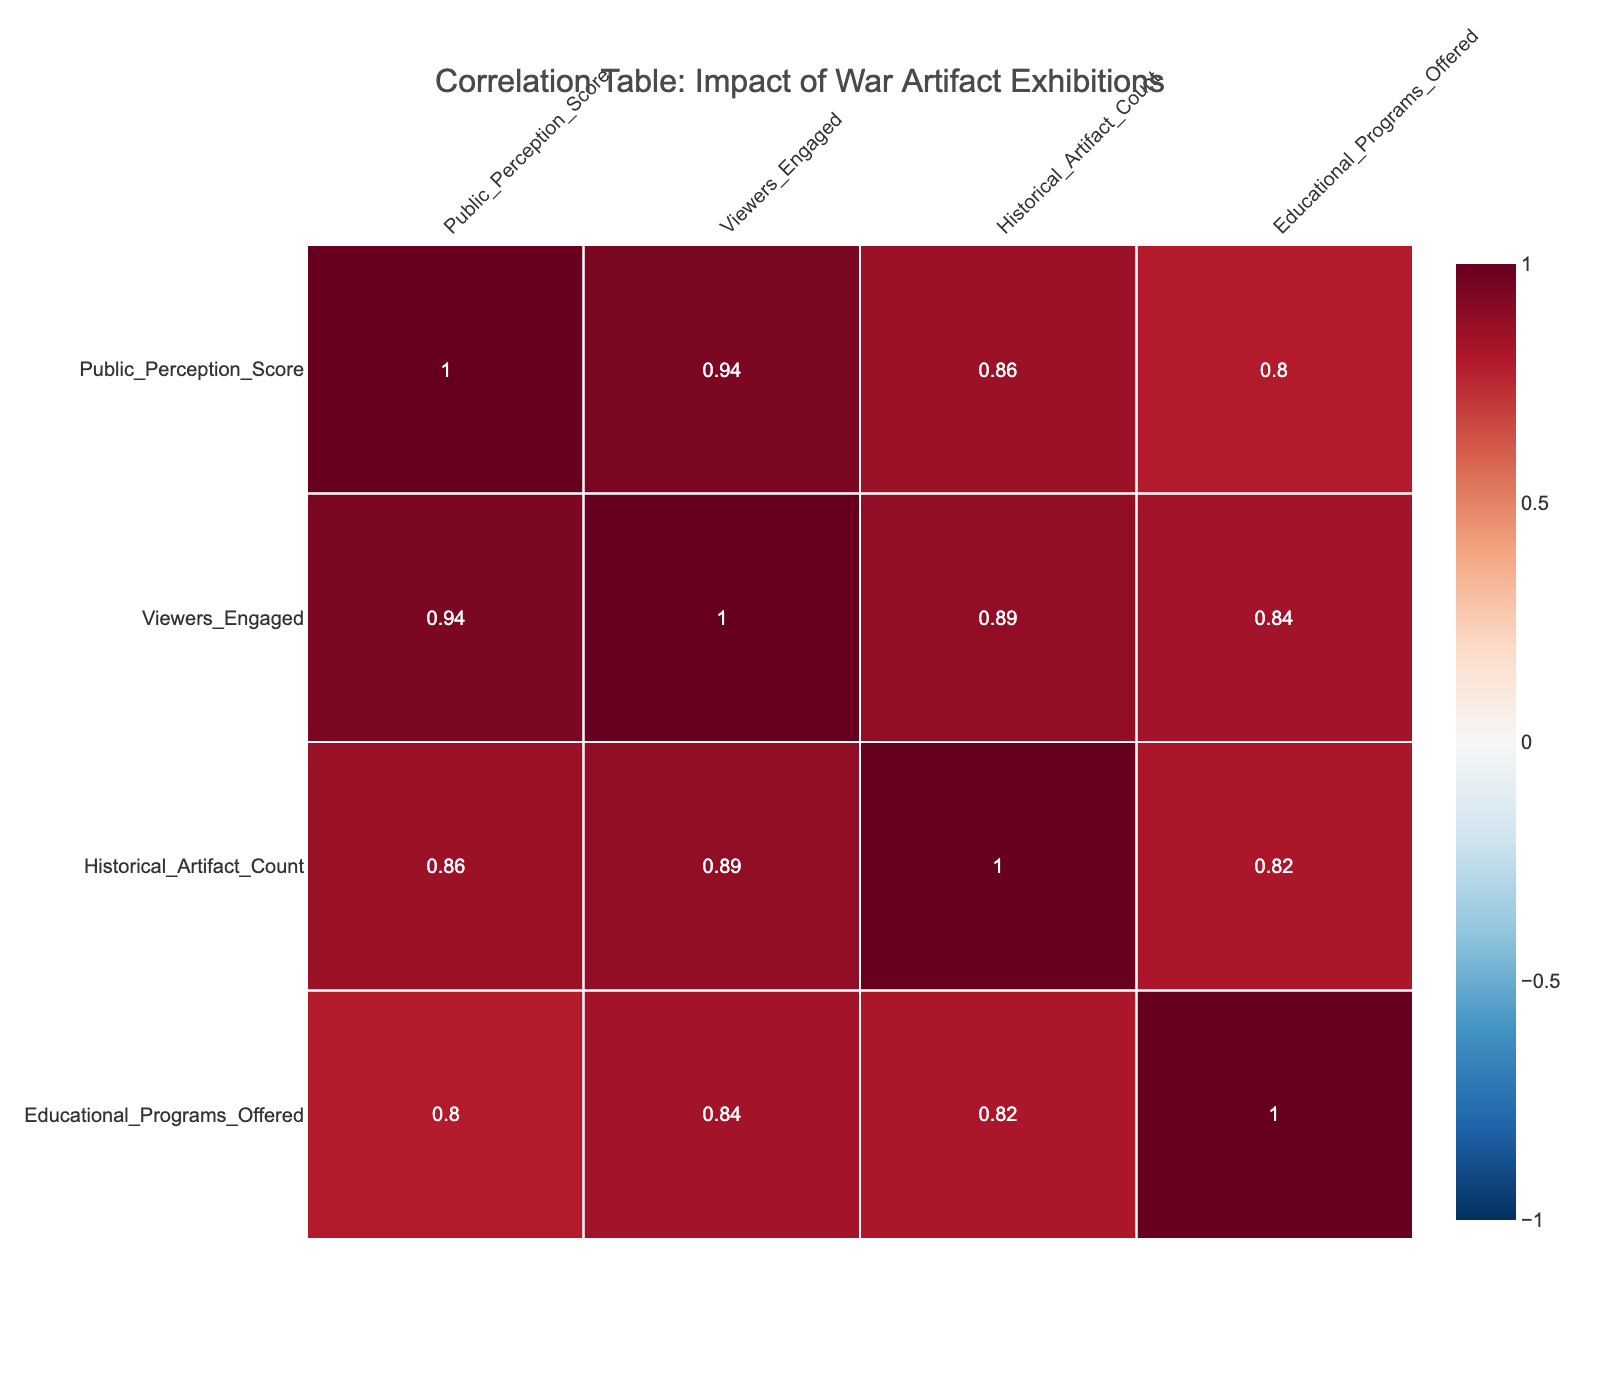What is the Public Perception Score of "Militaristic Displays: A Critical View"? The score for "Militaristic Displays: A Critical View" is listed directly in the table under the Public Perception Score. It shows a score of 48.
Answer: 48 What exhibition had the highest reported impact on violence? By examining the Reported Impact on Violence column, "Artifacts of Conflict: The Human Cost" has a high impact, which is higher than other exhibitions.
Answer: Artifacts of Conflict: The Human Cost What is the average Public Perception Score of exhibitions with a High reported impact on violence? The exhibitions with a High reported impact are "Artifacts of Conflict: The Human Cost" (82) and "War Through the Ages: A Commemorative Exhibit" (77). So, (82 + 77) / 2 = 79.5.
Answer: 79.5 Is it true that exhibitions with more Educational Programs Offered have higher Public Perception Scores? To check this, we need to compare the count of Educational Programs with their respective Public Perception Scores. While there are highs and lows, there is no conclusive pattern that supports a direct relationship across all data points. Thus, we cannot definitively confirm the statement.
Answer: No What is the total count of historical artifacts displayed across all exhibitions? By summing up the Historical Artifact Count for all exhibitions listed in the table: 50 + 75 + 30 + 60 + 40 + 20 + 35 + 80 + 45 + 25 = 490.
Answer: 490 What exhibition displayed the least number of historical artifacts, and what is the Public Perception Score for that exhibition? "Militaristic Displays: A Critical View" has the least count of historical artifacts displayed, which is 20. Its corresponding Public Perception Score is 48.
Answer: Militaristic Displays: A Critical View, 48 What is the correlation between Viewers Engaged and Public Perception Score? To determine the correlation, the values in the respective columns would need to be examined quantitatively. A high positive correlation could imply that more viewers might be associated with a higher perception score. However, the exact value is not provided in this format.
Answer: High positive correlation What exhibition has the least impact on violence, and how many viewers did it engage? "Legacy of War: Heroes or Villains?" has a reported impact of Very Low. It engaged 800 viewers according to the data.
Answer: Legacy of War: Heroes or Villains, 800 